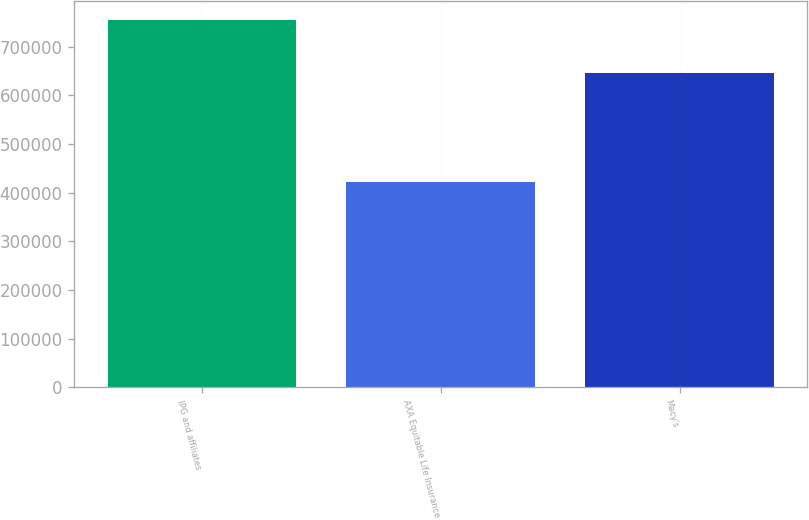<chart> <loc_0><loc_0><loc_500><loc_500><bar_chart><fcel>IPG and affiliates<fcel>AXA Equitable Life Insurance<fcel>Macy's<nl><fcel>755000<fcel>423000<fcel>646000<nl></chart> 